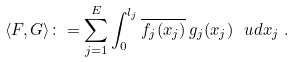<formula> <loc_0><loc_0><loc_500><loc_500>\langle F , G \rangle \colon = \sum _ { j = 1 } ^ { E } \int _ { 0 } ^ { l _ { j } } \overline { f _ { j } ( x _ { j } ) } \, g _ { j } ( x _ { j } ) \ \ u d x _ { j } \ .</formula> 